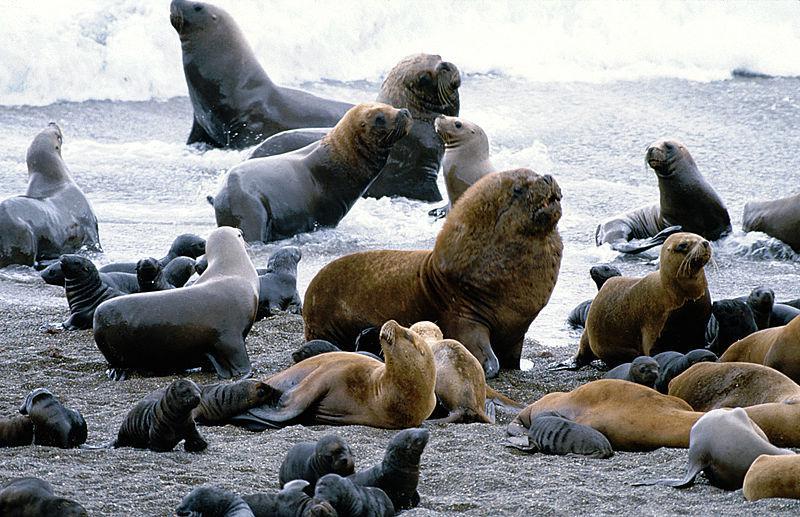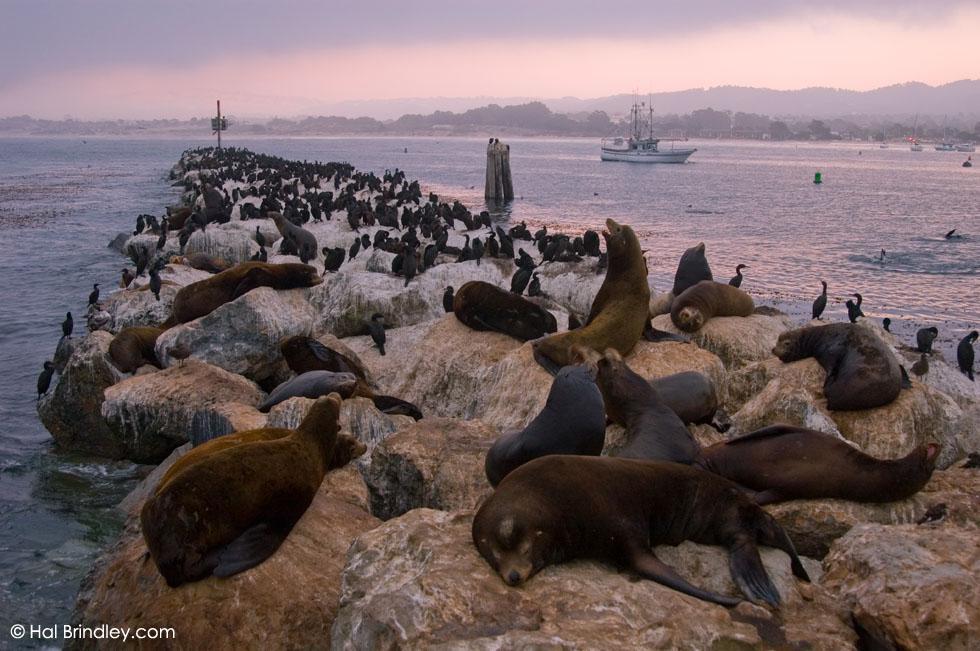The first image is the image on the left, the second image is the image on the right. Given the left and right images, does the statement "One image shows white spray from waves crashing where seals are gathered, and the other shows a mass of seals with no ocean background." hold true? Answer yes or no. No. The first image is the image on the left, the second image is the image on the right. Assess this claim about the two images: "There are multiple young pups with adults close to the edge of the water.". Correct or not? Answer yes or no. Yes. 